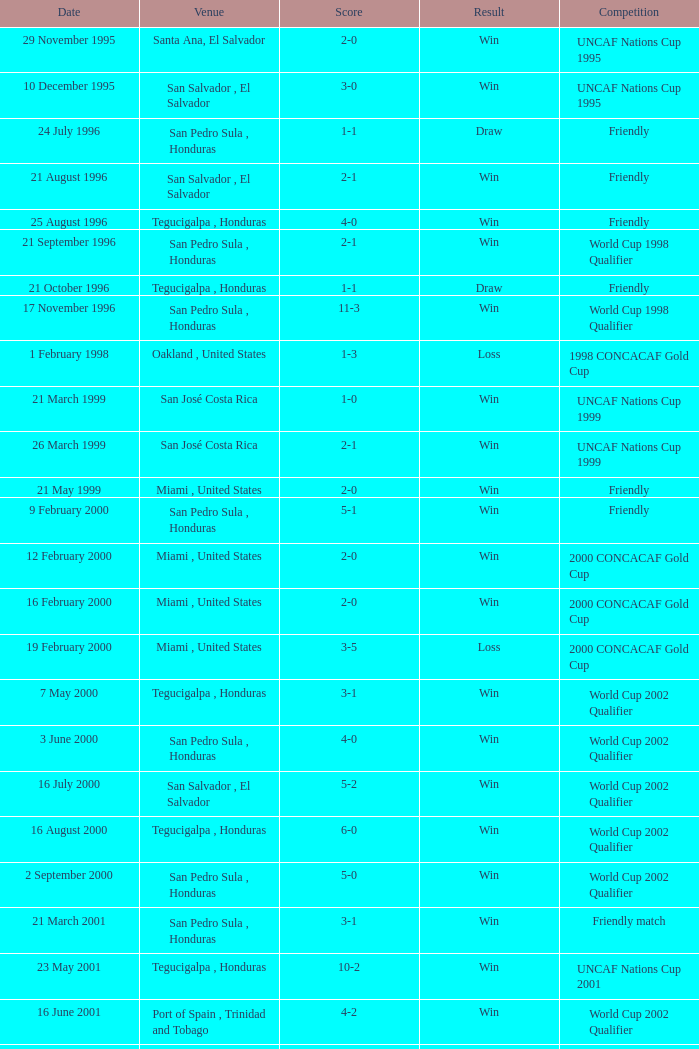Name the date of the uncaf nations cup 2009 26 January 2009. 